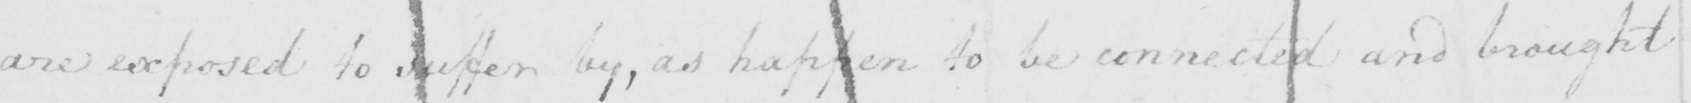What is written in this line of handwriting? are exposed to suffer by , as happen to be connected and brought 